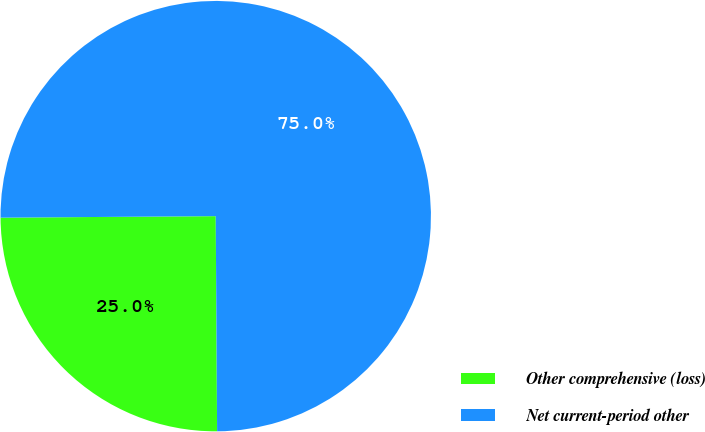Convert chart to OTSL. <chart><loc_0><loc_0><loc_500><loc_500><pie_chart><fcel>Other comprehensive (loss)<fcel>Net current-period other<nl><fcel>24.99%<fcel>75.01%<nl></chart> 